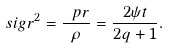<formula> <loc_0><loc_0><loc_500><loc_500>\ s i g r ^ { 2 } = \frac { \ p r } { \rho } = \frac { 2 \psi t } { 2 q + 1 } .</formula> 